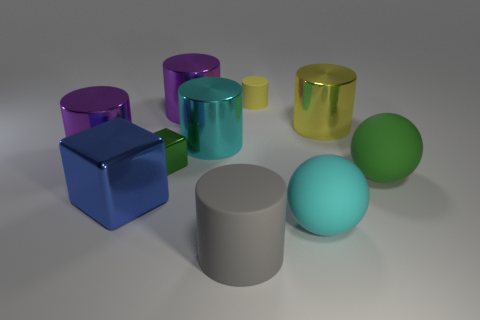Subtract all gray cubes. How many purple cylinders are left? 2 Subtract all big yellow cylinders. How many cylinders are left? 5 Subtract 4 cylinders. How many cylinders are left? 2 Subtract all yellow cylinders. How many cylinders are left? 4 Subtract all gray cylinders. Subtract all green spheres. How many cylinders are left? 5 Subtract all cubes. How many objects are left? 8 Add 5 tiny purple cubes. How many tiny purple cubes exist? 5 Subtract 1 green cubes. How many objects are left? 9 Subtract all cyan matte cylinders. Subtract all blocks. How many objects are left? 8 Add 4 big cyan matte things. How many big cyan matte things are left? 5 